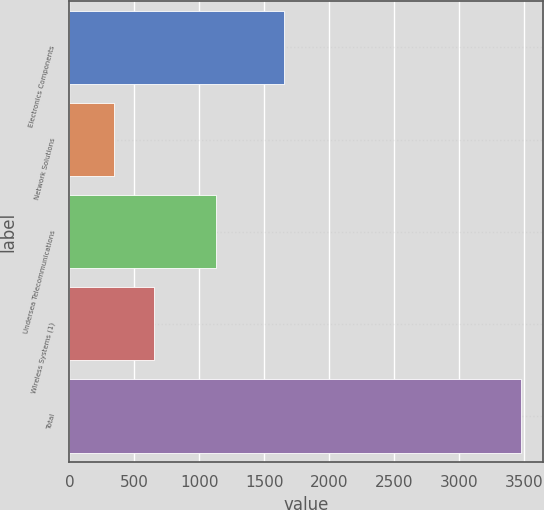Convert chart to OTSL. <chart><loc_0><loc_0><loc_500><loc_500><bar_chart><fcel>Electronics Components<fcel>Network Solutions<fcel>Undersea Telecommunications<fcel>Wireless Systems (1)<fcel>Total<nl><fcel>1655<fcel>339<fcel>1128<fcel>652.4<fcel>3473<nl></chart> 